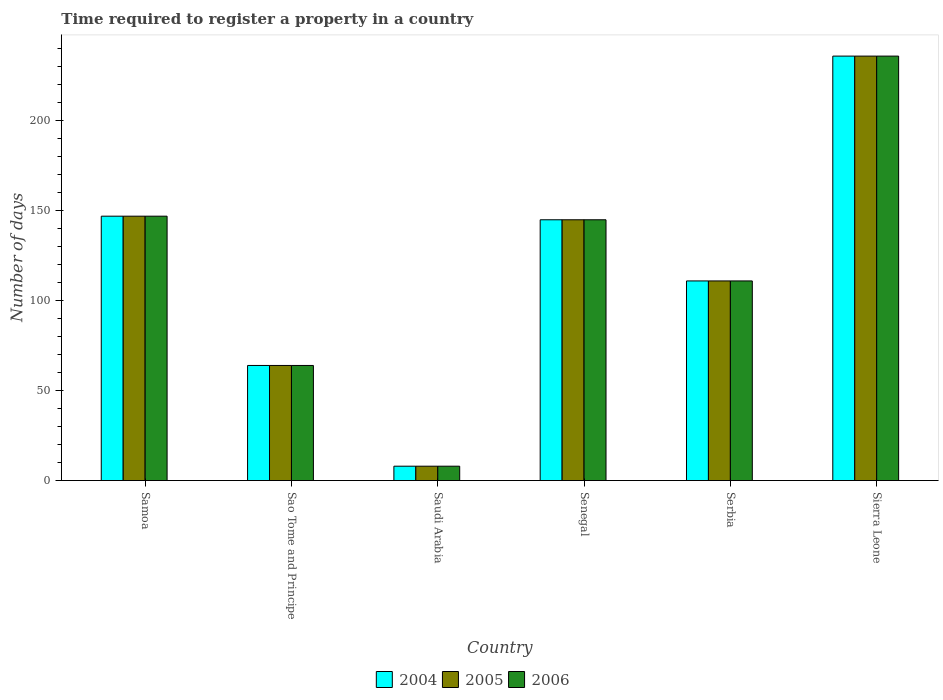How many different coloured bars are there?
Your response must be concise. 3. Are the number of bars on each tick of the X-axis equal?
Provide a succinct answer. Yes. How many bars are there on the 3rd tick from the left?
Offer a very short reply. 3. What is the label of the 2nd group of bars from the left?
Your answer should be very brief. Sao Tome and Principe. What is the number of days required to register a property in 2004 in Sao Tome and Principe?
Your answer should be very brief. 64. Across all countries, what is the maximum number of days required to register a property in 2006?
Ensure brevity in your answer.  236. Across all countries, what is the minimum number of days required to register a property in 2005?
Offer a terse response. 8. In which country was the number of days required to register a property in 2004 maximum?
Give a very brief answer. Sierra Leone. In which country was the number of days required to register a property in 2006 minimum?
Your answer should be very brief. Saudi Arabia. What is the total number of days required to register a property in 2006 in the graph?
Your answer should be very brief. 711. What is the difference between the number of days required to register a property in 2004 in Senegal and that in Sierra Leone?
Offer a terse response. -91. What is the difference between the number of days required to register a property in 2005 in Samoa and the number of days required to register a property in 2006 in Senegal?
Your response must be concise. 2. What is the average number of days required to register a property in 2005 per country?
Provide a short and direct response. 118.5. What is the difference between the number of days required to register a property of/in 2004 and number of days required to register a property of/in 2006 in Sierra Leone?
Your answer should be compact. 0. In how many countries, is the number of days required to register a property in 2005 greater than 60 days?
Make the answer very short. 5. What is the ratio of the number of days required to register a property in 2004 in Sao Tome and Principe to that in Senegal?
Ensure brevity in your answer.  0.44. What is the difference between the highest and the lowest number of days required to register a property in 2004?
Ensure brevity in your answer.  228. Is the sum of the number of days required to register a property in 2005 in Sao Tome and Principe and Serbia greater than the maximum number of days required to register a property in 2004 across all countries?
Offer a very short reply. No. What does the 3rd bar from the left in Senegal represents?
Your answer should be compact. 2006. What does the 2nd bar from the right in Sao Tome and Principe represents?
Your answer should be compact. 2005. Is it the case that in every country, the sum of the number of days required to register a property in 2005 and number of days required to register a property in 2006 is greater than the number of days required to register a property in 2004?
Provide a short and direct response. Yes. How many bars are there?
Make the answer very short. 18. Does the graph contain any zero values?
Offer a very short reply. No. Does the graph contain grids?
Keep it short and to the point. No. What is the title of the graph?
Offer a terse response. Time required to register a property in a country. Does "2005" appear as one of the legend labels in the graph?
Give a very brief answer. Yes. What is the label or title of the Y-axis?
Give a very brief answer. Number of days. What is the Number of days of 2004 in Samoa?
Offer a terse response. 147. What is the Number of days of 2005 in Samoa?
Make the answer very short. 147. What is the Number of days of 2006 in Samoa?
Your response must be concise. 147. What is the Number of days of 2004 in Sao Tome and Principe?
Provide a short and direct response. 64. What is the Number of days of 2006 in Sao Tome and Principe?
Give a very brief answer. 64. What is the Number of days in 2004 in Saudi Arabia?
Make the answer very short. 8. What is the Number of days in 2006 in Saudi Arabia?
Your answer should be compact. 8. What is the Number of days in 2004 in Senegal?
Provide a short and direct response. 145. What is the Number of days in 2005 in Senegal?
Provide a succinct answer. 145. What is the Number of days in 2006 in Senegal?
Keep it short and to the point. 145. What is the Number of days in 2004 in Serbia?
Your response must be concise. 111. What is the Number of days in 2005 in Serbia?
Provide a succinct answer. 111. What is the Number of days in 2006 in Serbia?
Your response must be concise. 111. What is the Number of days in 2004 in Sierra Leone?
Your answer should be very brief. 236. What is the Number of days in 2005 in Sierra Leone?
Keep it short and to the point. 236. What is the Number of days of 2006 in Sierra Leone?
Keep it short and to the point. 236. Across all countries, what is the maximum Number of days of 2004?
Ensure brevity in your answer.  236. Across all countries, what is the maximum Number of days in 2005?
Give a very brief answer. 236. Across all countries, what is the maximum Number of days in 2006?
Offer a terse response. 236. Across all countries, what is the minimum Number of days of 2004?
Your answer should be very brief. 8. What is the total Number of days in 2004 in the graph?
Offer a very short reply. 711. What is the total Number of days of 2005 in the graph?
Offer a terse response. 711. What is the total Number of days of 2006 in the graph?
Offer a terse response. 711. What is the difference between the Number of days in 2005 in Samoa and that in Sao Tome and Principe?
Your answer should be very brief. 83. What is the difference between the Number of days in 2006 in Samoa and that in Sao Tome and Principe?
Keep it short and to the point. 83. What is the difference between the Number of days in 2004 in Samoa and that in Saudi Arabia?
Your answer should be very brief. 139. What is the difference between the Number of days in 2005 in Samoa and that in Saudi Arabia?
Your answer should be very brief. 139. What is the difference between the Number of days of 2006 in Samoa and that in Saudi Arabia?
Provide a succinct answer. 139. What is the difference between the Number of days of 2004 in Samoa and that in Serbia?
Your response must be concise. 36. What is the difference between the Number of days of 2005 in Samoa and that in Serbia?
Your answer should be compact. 36. What is the difference between the Number of days of 2006 in Samoa and that in Serbia?
Your answer should be very brief. 36. What is the difference between the Number of days in 2004 in Samoa and that in Sierra Leone?
Provide a short and direct response. -89. What is the difference between the Number of days in 2005 in Samoa and that in Sierra Leone?
Provide a succinct answer. -89. What is the difference between the Number of days of 2006 in Samoa and that in Sierra Leone?
Your answer should be compact. -89. What is the difference between the Number of days of 2005 in Sao Tome and Principe and that in Saudi Arabia?
Your answer should be compact. 56. What is the difference between the Number of days of 2004 in Sao Tome and Principe and that in Senegal?
Your answer should be compact. -81. What is the difference between the Number of days in 2005 in Sao Tome and Principe and that in Senegal?
Provide a succinct answer. -81. What is the difference between the Number of days of 2006 in Sao Tome and Principe and that in Senegal?
Give a very brief answer. -81. What is the difference between the Number of days of 2004 in Sao Tome and Principe and that in Serbia?
Make the answer very short. -47. What is the difference between the Number of days of 2005 in Sao Tome and Principe and that in Serbia?
Ensure brevity in your answer.  -47. What is the difference between the Number of days in 2006 in Sao Tome and Principe and that in Serbia?
Your answer should be very brief. -47. What is the difference between the Number of days in 2004 in Sao Tome and Principe and that in Sierra Leone?
Make the answer very short. -172. What is the difference between the Number of days in 2005 in Sao Tome and Principe and that in Sierra Leone?
Offer a terse response. -172. What is the difference between the Number of days of 2006 in Sao Tome and Principe and that in Sierra Leone?
Give a very brief answer. -172. What is the difference between the Number of days of 2004 in Saudi Arabia and that in Senegal?
Provide a short and direct response. -137. What is the difference between the Number of days in 2005 in Saudi Arabia and that in Senegal?
Your response must be concise. -137. What is the difference between the Number of days in 2006 in Saudi Arabia and that in Senegal?
Your response must be concise. -137. What is the difference between the Number of days of 2004 in Saudi Arabia and that in Serbia?
Provide a succinct answer. -103. What is the difference between the Number of days in 2005 in Saudi Arabia and that in Serbia?
Give a very brief answer. -103. What is the difference between the Number of days in 2006 in Saudi Arabia and that in Serbia?
Your response must be concise. -103. What is the difference between the Number of days in 2004 in Saudi Arabia and that in Sierra Leone?
Your answer should be very brief. -228. What is the difference between the Number of days in 2005 in Saudi Arabia and that in Sierra Leone?
Your answer should be very brief. -228. What is the difference between the Number of days in 2006 in Saudi Arabia and that in Sierra Leone?
Provide a succinct answer. -228. What is the difference between the Number of days in 2004 in Senegal and that in Sierra Leone?
Offer a terse response. -91. What is the difference between the Number of days of 2005 in Senegal and that in Sierra Leone?
Offer a very short reply. -91. What is the difference between the Number of days in 2006 in Senegal and that in Sierra Leone?
Offer a terse response. -91. What is the difference between the Number of days in 2004 in Serbia and that in Sierra Leone?
Provide a short and direct response. -125. What is the difference between the Number of days of 2005 in Serbia and that in Sierra Leone?
Offer a very short reply. -125. What is the difference between the Number of days in 2006 in Serbia and that in Sierra Leone?
Keep it short and to the point. -125. What is the difference between the Number of days in 2004 in Samoa and the Number of days in 2005 in Sao Tome and Principe?
Keep it short and to the point. 83. What is the difference between the Number of days of 2004 in Samoa and the Number of days of 2005 in Saudi Arabia?
Offer a terse response. 139. What is the difference between the Number of days in 2004 in Samoa and the Number of days in 2006 in Saudi Arabia?
Keep it short and to the point. 139. What is the difference between the Number of days of 2005 in Samoa and the Number of days of 2006 in Saudi Arabia?
Keep it short and to the point. 139. What is the difference between the Number of days in 2004 in Samoa and the Number of days in 2005 in Senegal?
Your answer should be very brief. 2. What is the difference between the Number of days of 2004 in Samoa and the Number of days of 2005 in Serbia?
Your answer should be very brief. 36. What is the difference between the Number of days of 2004 in Samoa and the Number of days of 2006 in Serbia?
Provide a short and direct response. 36. What is the difference between the Number of days in 2005 in Samoa and the Number of days in 2006 in Serbia?
Keep it short and to the point. 36. What is the difference between the Number of days in 2004 in Samoa and the Number of days in 2005 in Sierra Leone?
Give a very brief answer. -89. What is the difference between the Number of days of 2004 in Samoa and the Number of days of 2006 in Sierra Leone?
Provide a short and direct response. -89. What is the difference between the Number of days in 2005 in Samoa and the Number of days in 2006 in Sierra Leone?
Keep it short and to the point. -89. What is the difference between the Number of days of 2004 in Sao Tome and Principe and the Number of days of 2005 in Saudi Arabia?
Provide a succinct answer. 56. What is the difference between the Number of days of 2004 in Sao Tome and Principe and the Number of days of 2006 in Saudi Arabia?
Your response must be concise. 56. What is the difference between the Number of days of 2005 in Sao Tome and Principe and the Number of days of 2006 in Saudi Arabia?
Keep it short and to the point. 56. What is the difference between the Number of days of 2004 in Sao Tome and Principe and the Number of days of 2005 in Senegal?
Your answer should be compact. -81. What is the difference between the Number of days of 2004 in Sao Tome and Principe and the Number of days of 2006 in Senegal?
Keep it short and to the point. -81. What is the difference between the Number of days in 2005 in Sao Tome and Principe and the Number of days in 2006 in Senegal?
Provide a succinct answer. -81. What is the difference between the Number of days in 2004 in Sao Tome and Principe and the Number of days in 2005 in Serbia?
Offer a very short reply. -47. What is the difference between the Number of days of 2004 in Sao Tome and Principe and the Number of days of 2006 in Serbia?
Provide a succinct answer. -47. What is the difference between the Number of days in 2005 in Sao Tome and Principe and the Number of days in 2006 in Serbia?
Provide a succinct answer. -47. What is the difference between the Number of days of 2004 in Sao Tome and Principe and the Number of days of 2005 in Sierra Leone?
Your response must be concise. -172. What is the difference between the Number of days in 2004 in Sao Tome and Principe and the Number of days in 2006 in Sierra Leone?
Provide a short and direct response. -172. What is the difference between the Number of days in 2005 in Sao Tome and Principe and the Number of days in 2006 in Sierra Leone?
Provide a short and direct response. -172. What is the difference between the Number of days in 2004 in Saudi Arabia and the Number of days in 2005 in Senegal?
Make the answer very short. -137. What is the difference between the Number of days in 2004 in Saudi Arabia and the Number of days in 2006 in Senegal?
Provide a short and direct response. -137. What is the difference between the Number of days of 2005 in Saudi Arabia and the Number of days of 2006 in Senegal?
Your response must be concise. -137. What is the difference between the Number of days of 2004 in Saudi Arabia and the Number of days of 2005 in Serbia?
Give a very brief answer. -103. What is the difference between the Number of days of 2004 in Saudi Arabia and the Number of days of 2006 in Serbia?
Your response must be concise. -103. What is the difference between the Number of days in 2005 in Saudi Arabia and the Number of days in 2006 in Serbia?
Your answer should be compact. -103. What is the difference between the Number of days of 2004 in Saudi Arabia and the Number of days of 2005 in Sierra Leone?
Your response must be concise. -228. What is the difference between the Number of days of 2004 in Saudi Arabia and the Number of days of 2006 in Sierra Leone?
Offer a terse response. -228. What is the difference between the Number of days of 2005 in Saudi Arabia and the Number of days of 2006 in Sierra Leone?
Your response must be concise. -228. What is the difference between the Number of days in 2004 in Senegal and the Number of days in 2006 in Serbia?
Offer a terse response. 34. What is the difference between the Number of days of 2004 in Senegal and the Number of days of 2005 in Sierra Leone?
Your answer should be very brief. -91. What is the difference between the Number of days in 2004 in Senegal and the Number of days in 2006 in Sierra Leone?
Ensure brevity in your answer.  -91. What is the difference between the Number of days in 2005 in Senegal and the Number of days in 2006 in Sierra Leone?
Offer a terse response. -91. What is the difference between the Number of days in 2004 in Serbia and the Number of days in 2005 in Sierra Leone?
Make the answer very short. -125. What is the difference between the Number of days in 2004 in Serbia and the Number of days in 2006 in Sierra Leone?
Give a very brief answer. -125. What is the difference between the Number of days of 2005 in Serbia and the Number of days of 2006 in Sierra Leone?
Keep it short and to the point. -125. What is the average Number of days of 2004 per country?
Give a very brief answer. 118.5. What is the average Number of days of 2005 per country?
Provide a short and direct response. 118.5. What is the average Number of days of 2006 per country?
Keep it short and to the point. 118.5. What is the difference between the Number of days in 2004 and Number of days in 2005 in Samoa?
Make the answer very short. 0. What is the difference between the Number of days of 2004 and Number of days of 2006 in Samoa?
Offer a very short reply. 0. What is the difference between the Number of days in 2005 and Number of days in 2006 in Samoa?
Provide a short and direct response. 0. What is the difference between the Number of days in 2004 and Number of days in 2005 in Sao Tome and Principe?
Keep it short and to the point. 0. What is the difference between the Number of days of 2005 and Number of days of 2006 in Sao Tome and Principe?
Ensure brevity in your answer.  0. What is the difference between the Number of days in 2004 and Number of days in 2005 in Saudi Arabia?
Your response must be concise. 0. What is the difference between the Number of days of 2004 and Number of days of 2006 in Saudi Arabia?
Your answer should be compact. 0. What is the difference between the Number of days of 2004 and Number of days of 2005 in Serbia?
Your answer should be compact. 0. What is the difference between the Number of days in 2005 and Number of days in 2006 in Sierra Leone?
Ensure brevity in your answer.  0. What is the ratio of the Number of days in 2004 in Samoa to that in Sao Tome and Principe?
Ensure brevity in your answer.  2.3. What is the ratio of the Number of days of 2005 in Samoa to that in Sao Tome and Principe?
Provide a short and direct response. 2.3. What is the ratio of the Number of days in 2006 in Samoa to that in Sao Tome and Principe?
Your answer should be very brief. 2.3. What is the ratio of the Number of days of 2004 in Samoa to that in Saudi Arabia?
Your response must be concise. 18.38. What is the ratio of the Number of days in 2005 in Samoa to that in Saudi Arabia?
Give a very brief answer. 18.38. What is the ratio of the Number of days in 2006 in Samoa to that in Saudi Arabia?
Make the answer very short. 18.38. What is the ratio of the Number of days in 2004 in Samoa to that in Senegal?
Offer a very short reply. 1.01. What is the ratio of the Number of days in 2005 in Samoa to that in Senegal?
Provide a succinct answer. 1.01. What is the ratio of the Number of days in 2006 in Samoa to that in Senegal?
Offer a very short reply. 1.01. What is the ratio of the Number of days of 2004 in Samoa to that in Serbia?
Provide a short and direct response. 1.32. What is the ratio of the Number of days in 2005 in Samoa to that in Serbia?
Offer a terse response. 1.32. What is the ratio of the Number of days in 2006 in Samoa to that in Serbia?
Your answer should be compact. 1.32. What is the ratio of the Number of days in 2004 in Samoa to that in Sierra Leone?
Give a very brief answer. 0.62. What is the ratio of the Number of days in 2005 in Samoa to that in Sierra Leone?
Your answer should be compact. 0.62. What is the ratio of the Number of days in 2006 in Samoa to that in Sierra Leone?
Your answer should be very brief. 0.62. What is the ratio of the Number of days in 2005 in Sao Tome and Principe to that in Saudi Arabia?
Provide a succinct answer. 8. What is the ratio of the Number of days in 2006 in Sao Tome and Principe to that in Saudi Arabia?
Your response must be concise. 8. What is the ratio of the Number of days in 2004 in Sao Tome and Principe to that in Senegal?
Your answer should be compact. 0.44. What is the ratio of the Number of days in 2005 in Sao Tome and Principe to that in Senegal?
Give a very brief answer. 0.44. What is the ratio of the Number of days in 2006 in Sao Tome and Principe to that in Senegal?
Your answer should be compact. 0.44. What is the ratio of the Number of days of 2004 in Sao Tome and Principe to that in Serbia?
Your answer should be compact. 0.58. What is the ratio of the Number of days of 2005 in Sao Tome and Principe to that in Serbia?
Make the answer very short. 0.58. What is the ratio of the Number of days of 2006 in Sao Tome and Principe to that in Serbia?
Offer a terse response. 0.58. What is the ratio of the Number of days in 2004 in Sao Tome and Principe to that in Sierra Leone?
Make the answer very short. 0.27. What is the ratio of the Number of days of 2005 in Sao Tome and Principe to that in Sierra Leone?
Offer a very short reply. 0.27. What is the ratio of the Number of days in 2006 in Sao Tome and Principe to that in Sierra Leone?
Your answer should be compact. 0.27. What is the ratio of the Number of days in 2004 in Saudi Arabia to that in Senegal?
Provide a short and direct response. 0.06. What is the ratio of the Number of days of 2005 in Saudi Arabia to that in Senegal?
Your answer should be compact. 0.06. What is the ratio of the Number of days in 2006 in Saudi Arabia to that in Senegal?
Make the answer very short. 0.06. What is the ratio of the Number of days in 2004 in Saudi Arabia to that in Serbia?
Ensure brevity in your answer.  0.07. What is the ratio of the Number of days of 2005 in Saudi Arabia to that in Serbia?
Give a very brief answer. 0.07. What is the ratio of the Number of days in 2006 in Saudi Arabia to that in Serbia?
Your response must be concise. 0.07. What is the ratio of the Number of days of 2004 in Saudi Arabia to that in Sierra Leone?
Your answer should be compact. 0.03. What is the ratio of the Number of days of 2005 in Saudi Arabia to that in Sierra Leone?
Make the answer very short. 0.03. What is the ratio of the Number of days of 2006 in Saudi Arabia to that in Sierra Leone?
Ensure brevity in your answer.  0.03. What is the ratio of the Number of days in 2004 in Senegal to that in Serbia?
Your answer should be very brief. 1.31. What is the ratio of the Number of days in 2005 in Senegal to that in Serbia?
Your response must be concise. 1.31. What is the ratio of the Number of days of 2006 in Senegal to that in Serbia?
Make the answer very short. 1.31. What is the ratio of the Number of days in 2004 in Senegal to that in Sierra Leone?
Your answer should be compact. 0.61. What is the ratio of the Number of days of 2005 in Senegal to that in Sierra Leone?
Ensure brevity in your answer.  0.61. What is the ratio of the Number of days in 2006 in Senegal to that in Sierra Leone?
Keep it short and to the point. 0.61. What is the ratio of the Number of days in 2004 in Serbia to that in Sierra Leone?
Ensure brevity in your answer.  0.47. What is the ratio of the Number of days of 2005 in Serbia to that in Sierra Leone?
Provide a succinct answer. 0.47. What is the ratio of the Number of days in 2006 in Serbia to that in Sierra Leone?
Provide a short and direct response. 0.47. What is the difference between the highest and the second highest Number of days in 2004?
Make the answer very short. 89. What is the difference between the highest and the second highest Number of days of 2005?
Offer a terse response. 89. What is the difference between the highest and the second highest Number of days of 2006?
Make the answer very short. 89. What is the difference between the highest and the lowest Number of days in 2004?
Your answer should be compact. 228. What is the difference between the highest and the lowest Number of days of 2005?
Provide a succinct answer. 228. What is the difference between the highest and the lowest Number of days of 2006?
Offer a very short reply. 228. 